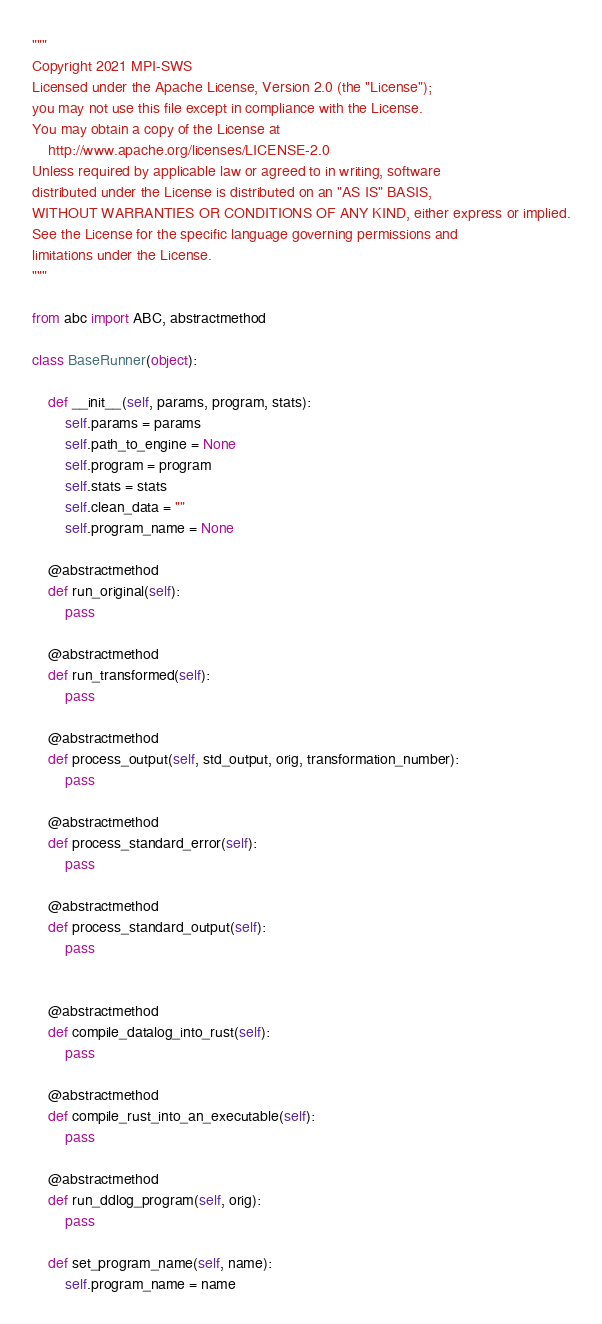Convert code to text. <code><loc_0><loc_0><loc_500><loc_500><_Python_>"""
Copyright 2021 MPI-SWS
Licensed under the Apache License, Version 2.0 (the "License");
you may not use this file except in compliance with the License.
You may obtain a copy of the License at
    http://www.apache.org/licenses/LICENSE-2.0
Unless required by applicable law or agreed to in writing, software
distributed under the License is distributed on an "AS IS" BASIS,
WITHOUT WARRANTIES OR CONDITIONS OF ANY KIND, either express or implied.
See the License for the specific language governing permissions and
limitations under the License.
"""

from abc import ABC, abstractmethod

class BaseRunner(object):

    def __init__(self, params, program, stats):
        self.params = params
        self.path_to_engine = None
        self.program = program
        self.stats = stats
        self.clean_data = ""
        self.program_name = None

    @abstractmethod
    def run_original(self):
        pass

    @abstractmethod
    def run_transformed(self):
        pass

    @abstractmethod
    def process_output(self, std_output, orig, transformation_number):
        pass

    @abstractmethod
    def process_standard_error(self):
        pass

    @abstractmethod
    def process_standard_output(self):
        pass


    @abstractmethod
    def compile_datalog_into_rust(self):
        pass

    @abstractmethod
    def compile_rust_into_an_executable(self):
        pass

    @abstractmethod
    def run_ddlog_program(self, orig):
        pass

    def set_program_name(self, name):
        self.program_name = name</code> 